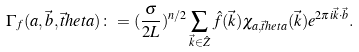Convert formula to latex. <formula><loc_0><loc_0><loc_500><loc_500>\Gamma _ { f } ( a , \vec { b } , \vec { t } h e t a ) \colon = ( \frac { \sigma } { 2 L } ) ^ { n / 2 } \sum _ { \vec { k } \in \hat { Z } } \hat { f } ( \vec { k } ) \chi _ { a , \vec { t } h e t a } ( \vec { k } ) e ^ { 2 \pi i \vec { k } \cdot \vec { b } } .</formula> 